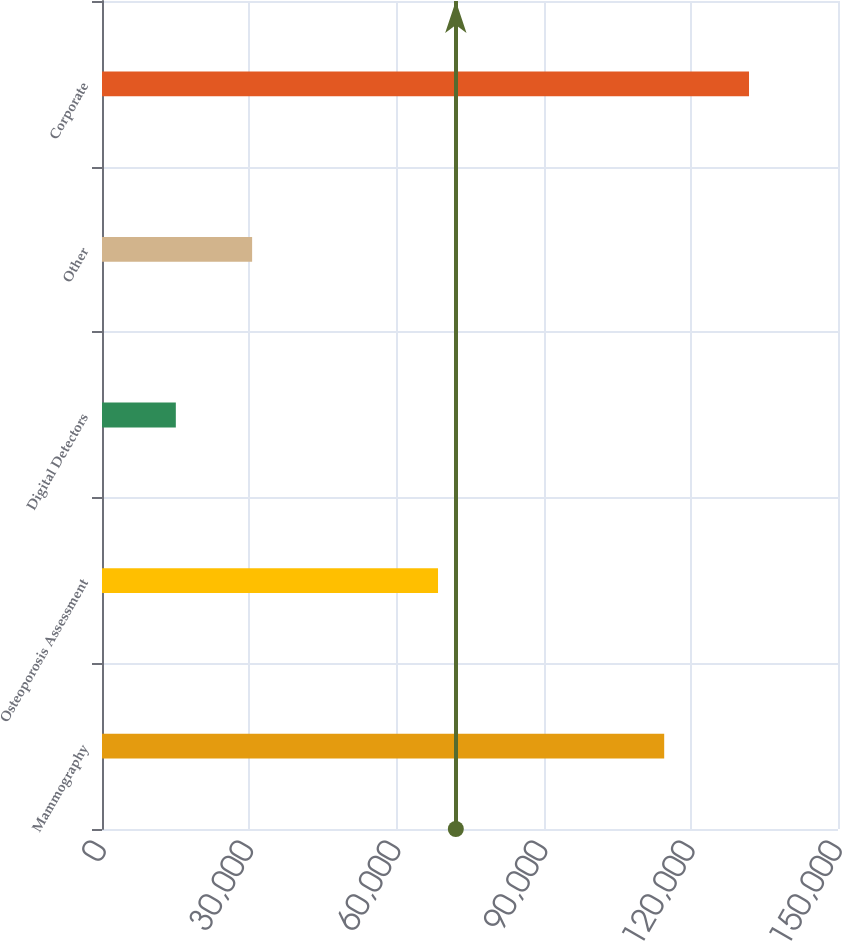<chart> <loc_0><loc_0><loc_500><loc_500><bar_chart><fcel>Mammography<fcel>Osteoporosis Assessment<fcel>Digital Detectors<fcel>Other<fcel>Corporate<nl><fcel>114579<fcel>68483<fcel>15047<fcel>30596<fcel>131865<nl></chart> 